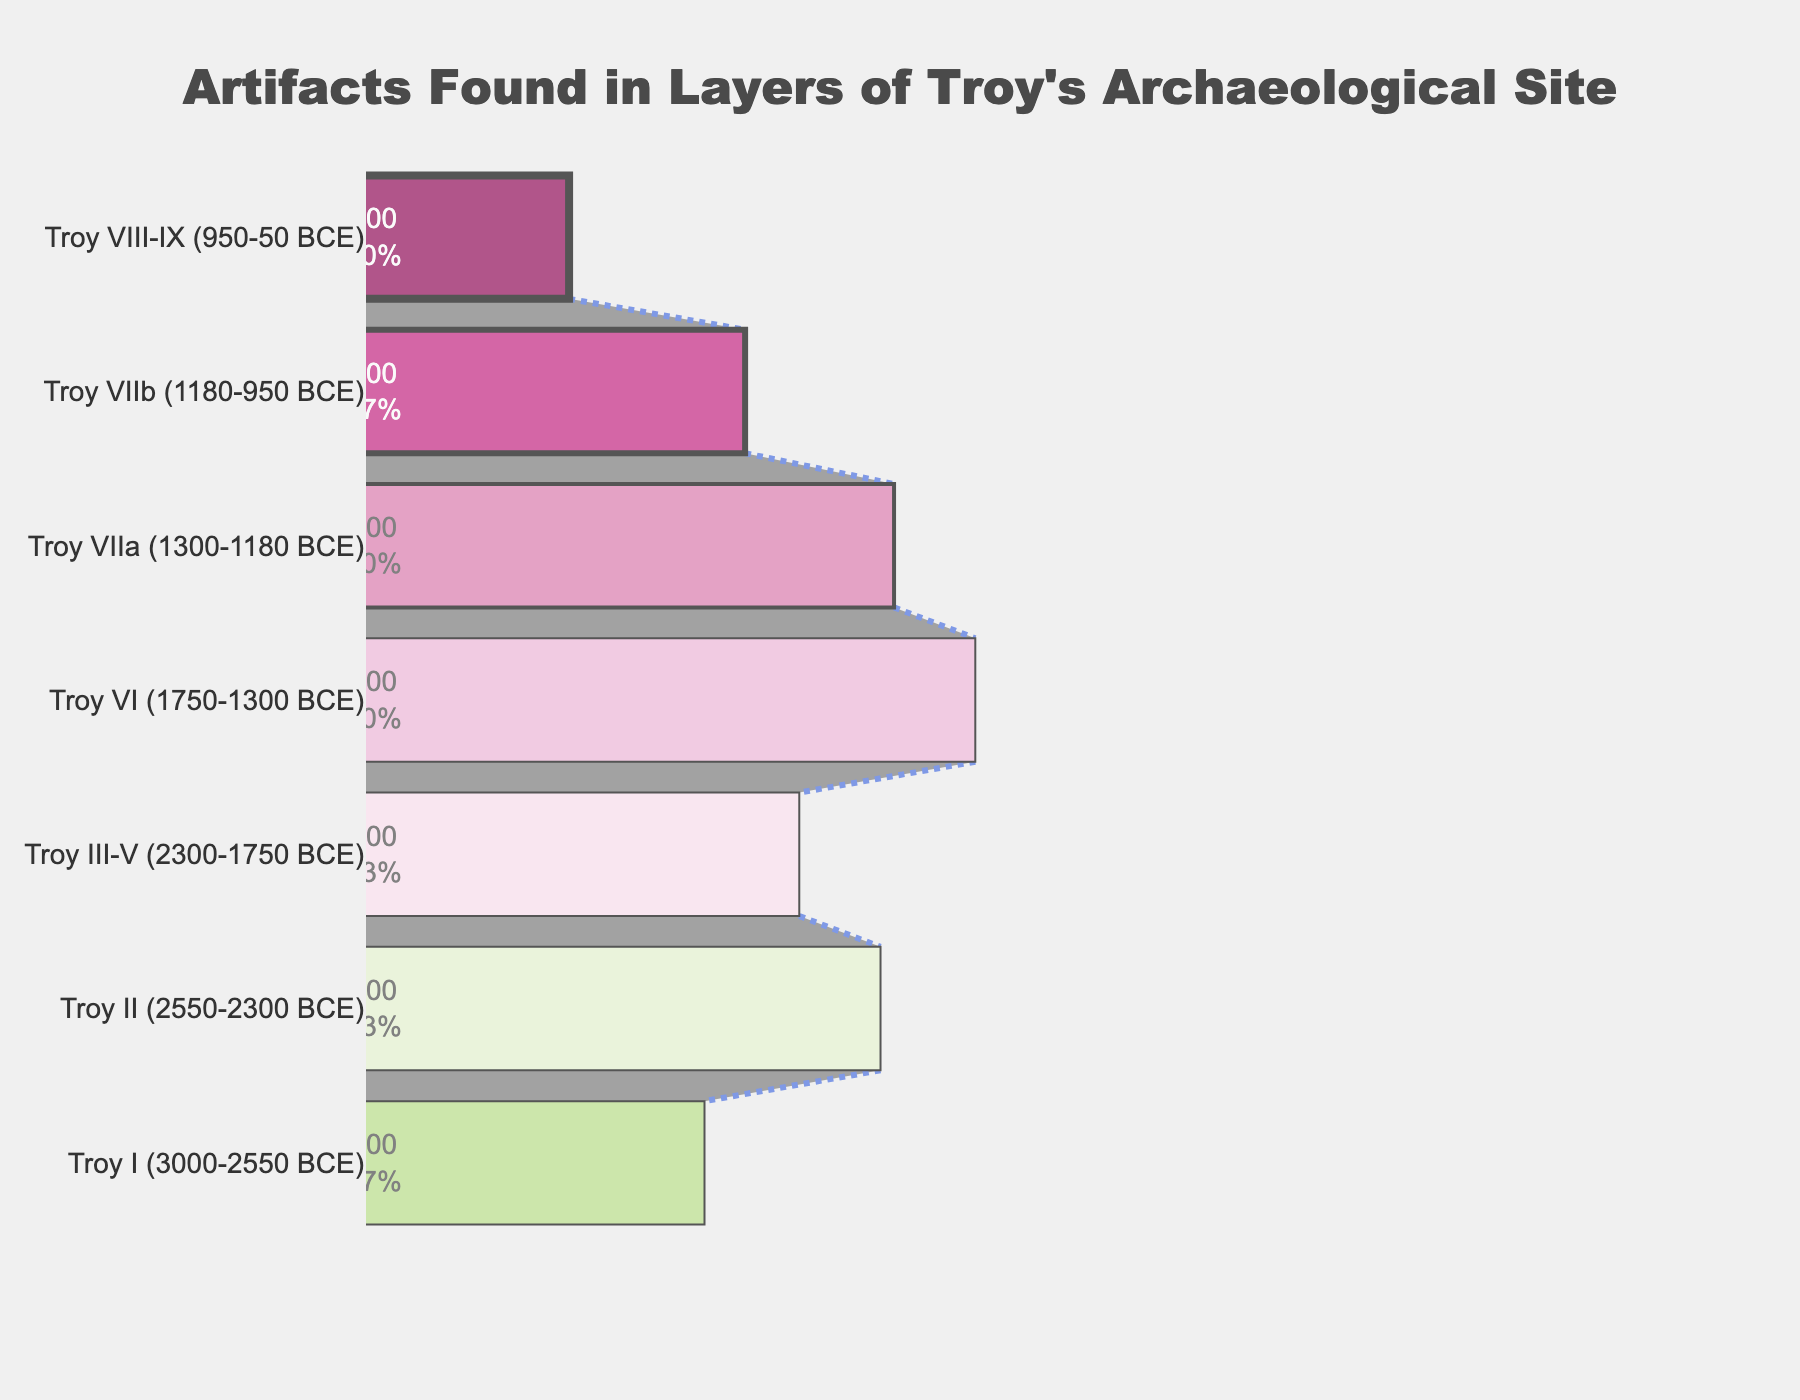What is the title of the funnel chart? The title is displayed prominently at the top of the chart, indicating the main theme or insight it represents.
Answer: Artifacts Found in Layers of Troy's Archaeological Site How many layers are represented in the funnel chart? The y-axis lists all the different layers, and by counting them, we can determine the number of layers represented.
Answer: 7 Which layer has the highest number of artifacts found? By looking at the x-axis values, the layer with the longest bar represents the highest number of artifacts. Troy VI has the longest bar with 4500 artifacts.
Answer: Troy VI Which layer has the lowest number of artifacts found? By observing the shortest bar on the funnel chart, Troy VIII-IX has the least number of artifacts found at 1500.
Answer: Troy VIII-IX What is the total number of artifacts found across all layers? To find the total, we add the number of artifacts for each layer: 2500 + 3800 + 3200 + 4500 + 3900 + 2800 + 1500 = 22200.
Answer: 22200 How many artifacts were found in Troy I and Troy II combined? Sum the number of artifacts from Troy I and Troy II: 2500 + 3800 = 6300.
Answer: 6300 What is the difference in the number of artifacts found between Troy VI and Troy VIIa? Subtract the number of artifacts in Troy VIIa from Troy VI: 4500 - 3900 = 600.
Answer: 600 Which layers have more than 3000 artifacts found? Layers with bars extending beyond 3000 on the x-axis meet this criterion. These are Troy II, Troy III-V, Troy VI, and Troy VIIa.
Answer: Troy II, Troy III-V, Troy VI, and Troy VIIa What percentage of the total artifacts were found in Troy VI? To find the percentage, use the formula: (number of artifacts in Troy VI / total number of artifacts) * 100 = (4500 / 22200) * 100 ≈ 20.27%.
Answer: ~20.27% How many layers have artifact counts between 2000 and 4000? By counting the bars with values falling within this range, layers Troy I, Troy III-V, Troy VIIa, and Troy VIIb meet this criterion.
Answer: 4 